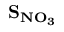<formula> <loc_0><loc_0><loc_500><loc_500>S _ { N O _ { 3 } }</formula> 